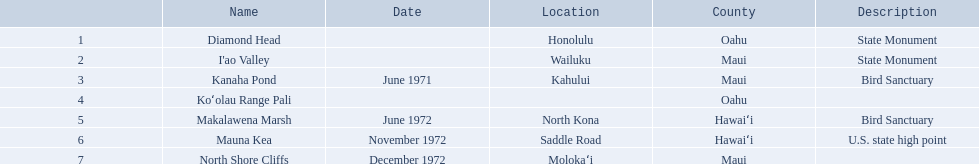What are the names of every notable landmark in hawaii? Diamond Head, I'ao Valley, Kanaha Pond, Koʻolau Range Pali, Makalawena Marsh, Mauna Kea, North Shore Cliffs. What are their features? State Monument, State Monument, Bird Sanctuary, , Bird Sanctuary, U.S. state high point, . And which one is considered as a u.s. state high point? Mauna Kea. Which national natural landmarks in hawaii can be found in oahu county? Diamond Head, Koʻolau Range Pali. Of these landmarks, which one is recorded without a location? Koʻolau Range Pali. 